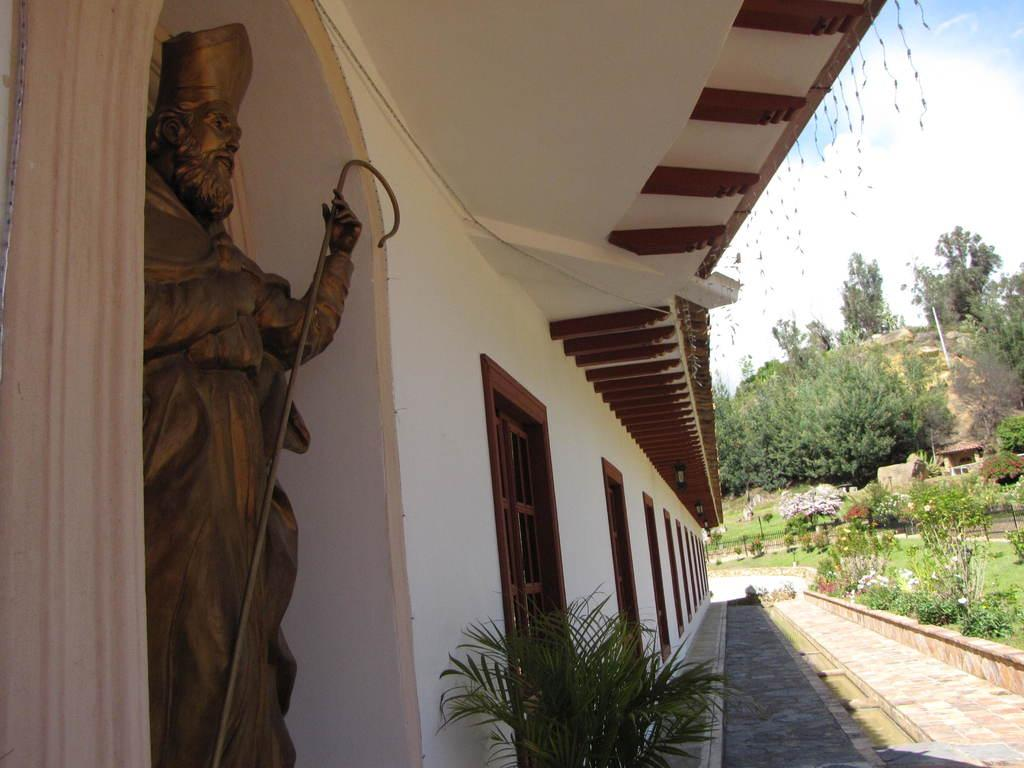What is the main subject in the image? There is a statue in the image. What else can be seen in the image besides the statue? There is a building, plants, grass, trees, and a pole visible in the image. What is the background of the image composed of? The background of the image includes trees, a pole, and the sky. How does the statue remain quiet in the image? The statue is not capable of making noise or being quiet, as it is an inanimate object. 